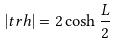<formula> <loc_0><loc_0><loc_500><loc_500>| t r h | = 2 \cosh \frac { L } { 2 }</formula> 